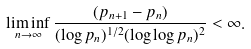Convert formula to latex. <formula><loc_0><loc_0><loc_500><loc_500>\liminf _ { n \to \infty } \frac { ( p _ { n + 1 } - p _ { n } ) } { ( \log p _ { n } ) ^ { 1 / 2 } ( \log \log p _ { n } ) ^ { 2 } } < \infty .</formula> 